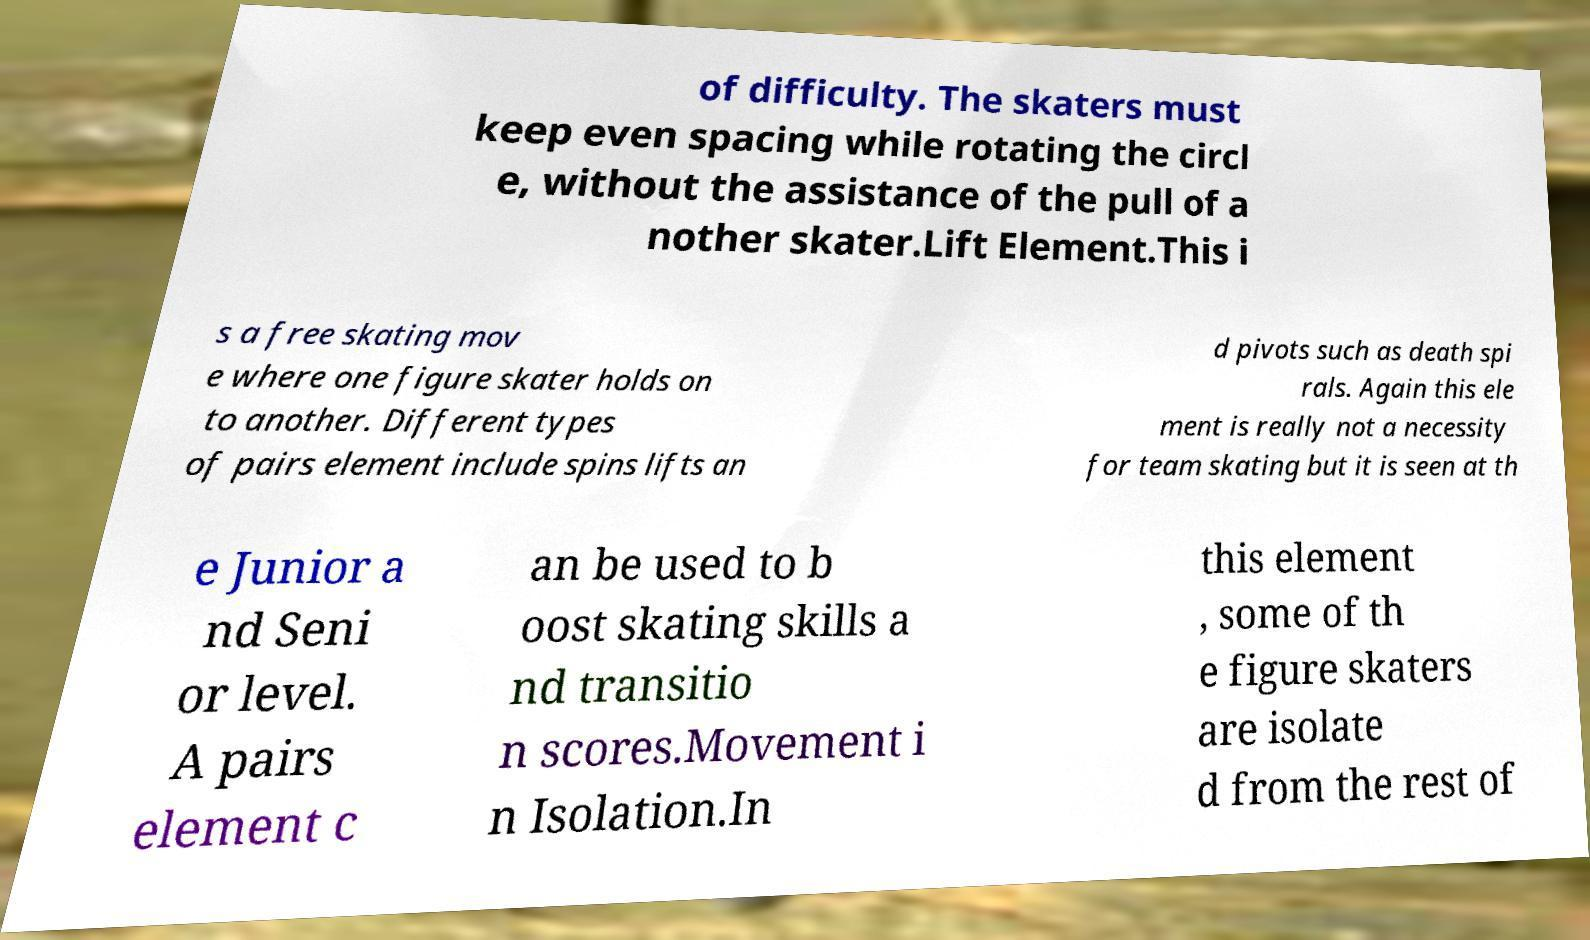Please identify and transcribe the text found in this image. of difficulty. The skaters must keep even spacing while rotating the circl e, without the assistance of the pull of a nother skater.Lift Element.This i s a free skating mov e where one figure skater holds on to another. Different types of pairs element include spins lifts an d pivots such as death spi rals. Again this ele ment is really not a necessity for team skating but it is seen at th e Junior a nd Seni or level. A pairs element c an be used to b oost skating skills a nd transitio n scores.Movement i n Isolation.In this element , some of th e figure skaters are isolate d from the rest of 